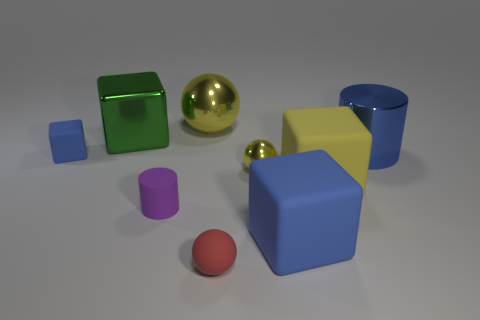What number of small cyan matte balls are there?
Your answer should be very brief. 0. Is there a yellow metal cube of the same size as the red sphere?
Provide a succinct answer. No. Is the number of large blue shiny cylinders that are in front of the yellow block less than the number of brown metal things?
Keep it short and to the point. No. Is the blue metallic cylinder the same size as the yellow rubber object?
Keep it short and to the point. Yes. What is the size of the yellow cube that is the same material as the purple cylinder?
Your answer should be very brief. Large. How many matte spheres have the same color as the metallic cylinder?
Give a very brief answer. 0. Is the number of green cubes on the left side of the big blue metal cylinder less than the number of small blue rubber cubes that are left of the big green thing?
Provide a short and direct response. No. There is a tiny purple thing that is left of the yellow matte object; is its shape the same as the yellow matte thing?
Offer a very short reply. No. Is there any other thing that is the same material as the small red ball?
Keep it short and to the point. Yes. Is the yellow sphere that is in front of the large yellow metal object made of the same material as the yellow block?
Offer a terse response. No. 